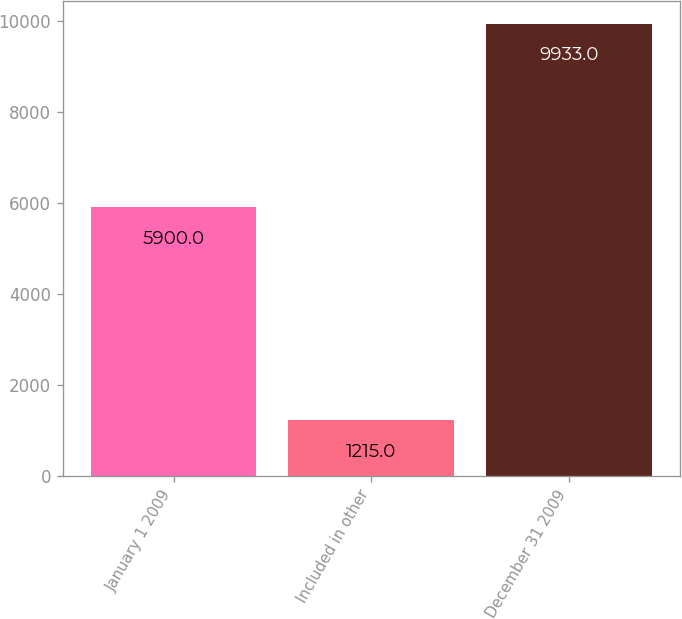Convert chart. <chart><loc_0><loc_0><loc_500><loc_500><bar_chart><fcel>January 1 2009<fcel>Included in other<fcel>December 31 2009<nl><fcel>5900<fcel>1215<fcel>9933<nl></chart> 